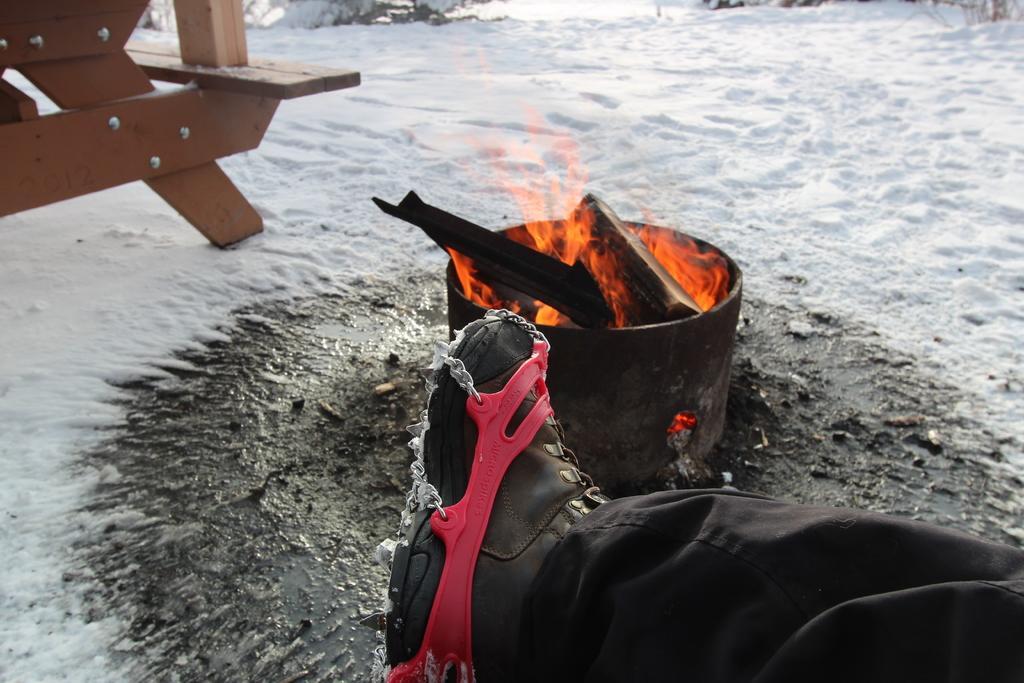How would you summarize this image in a sentence or two? In this image I can see the person's leg. The person is on the snow. The person is wearing the black color dress and shoes. To the side there is a fire. To the left I can see the bench. 